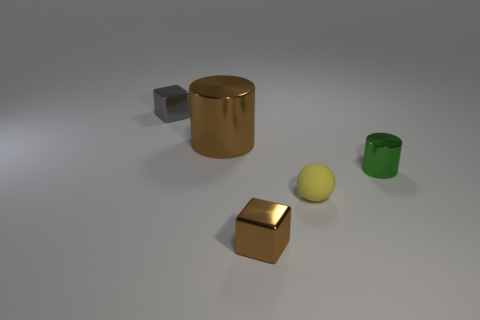How many cylinders are either large objects or brown shiny things?
Provide a succinct answer. 1. The small object that is both to the left of the tiny sphere and behind the small yellow rubber thing has what shape?
Provide a succinct answer. Cube. Is there a gray metal cube of the same size as the yellow rubber object?
Ensure brevity in your answer.  Yes. How many objects are either tiny objects on the right side of the brown metallic block or green blocks?
Make the answer very short. 2. Is the tiny yellow ball made of the same material as the small object behind the small green metallic cylinder?
Ensure brevity in your answer.  No. What number of other things are the same shape as the small yellow rubber thing?
Provide a succinct answer. 0. How many things are tiny metallic cubes that are in front of the gray metal thing or metallic blocks in front of the small cylinder?
Offer a very short reply. 1. What number of other objects are there of the same color as the tiny rubber object?
Your response must be concise. 0. Are there fewer green cylinders in front of the yellow object than big brown shiny objects left of the tiny green shiny thing?
Your answer should be very brief. Yes. What number of large green rubber cylinders are there?
Your answer should be very brief. 0. 